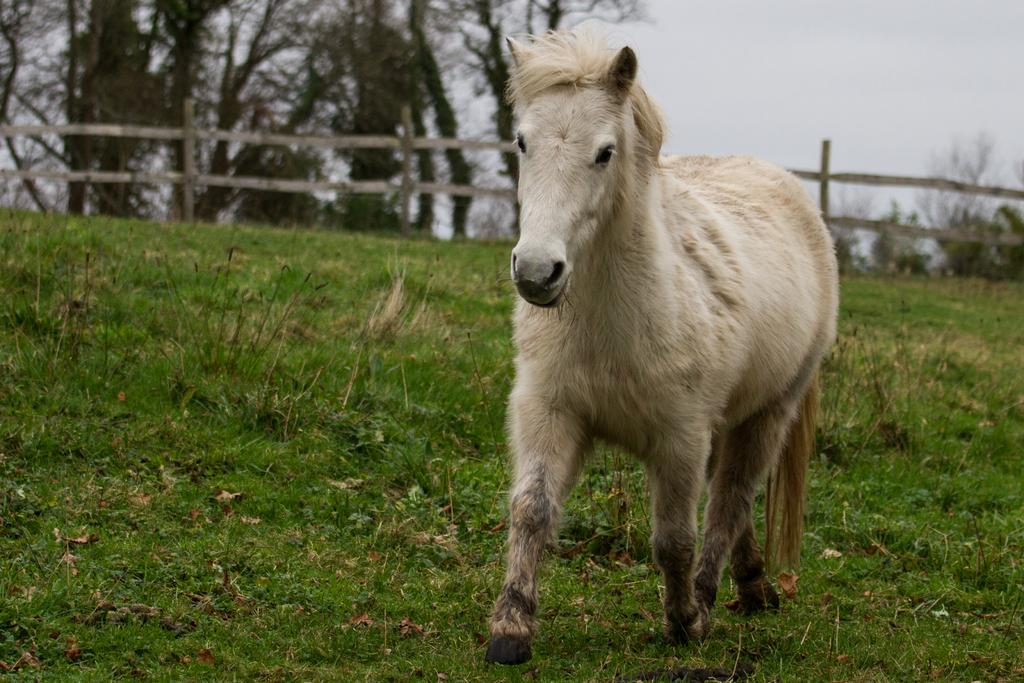What animal is the main subject of the image? There is a white horse in the image. What is the horse doing in the image? The horse is running on the grass. Can you describe the background of the image? The background of the image is blurred, and there is a fence, trees, and the sky visible. What type of lamp can be seen illuminating the morning scene in the image? There is no lamp present in the image, and the time of day is not specified. 